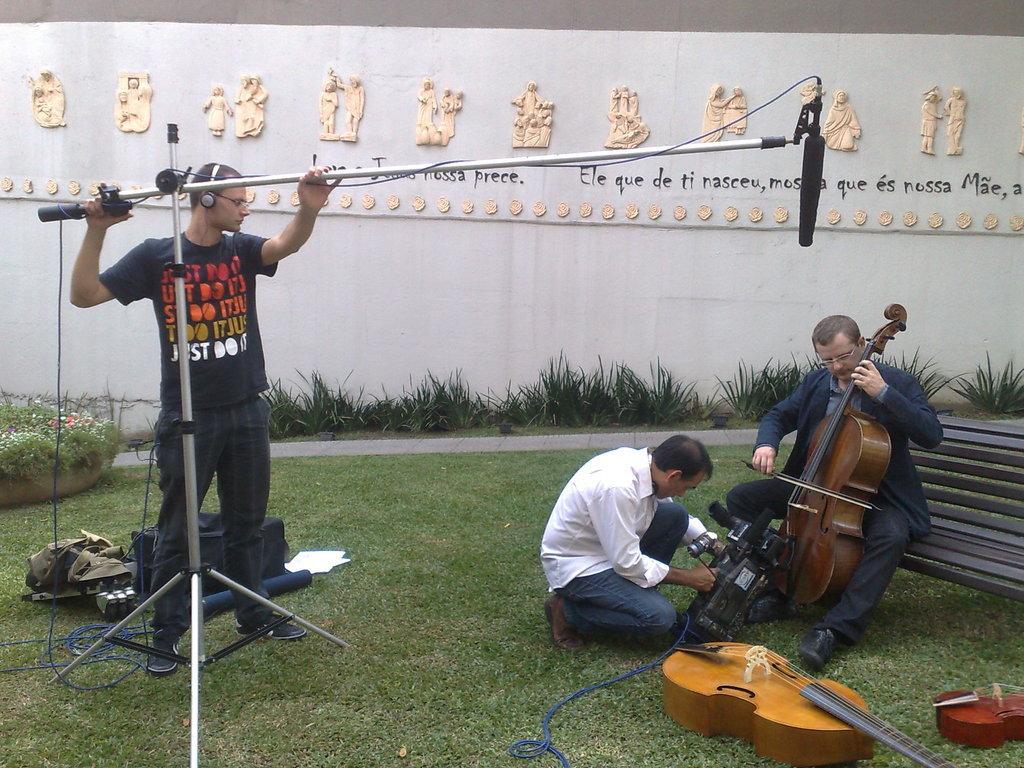In one or two sentences, can you explain what this image depicts? On wall there are sculptures. This is grass This person is holding a stand. This person is playing a violin. This person is holding a camera. On grass there is a violin. These are plants. This is bench. 